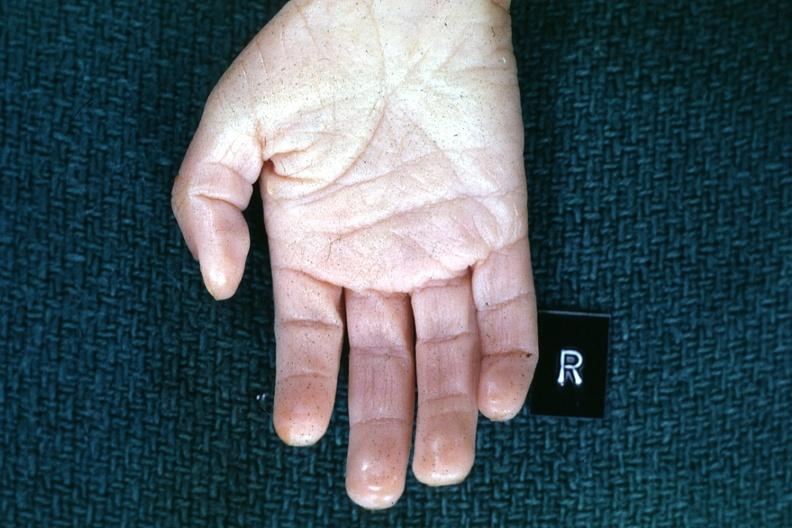does this image show right hand?
Answer the question using a single word or phrase. Yes 